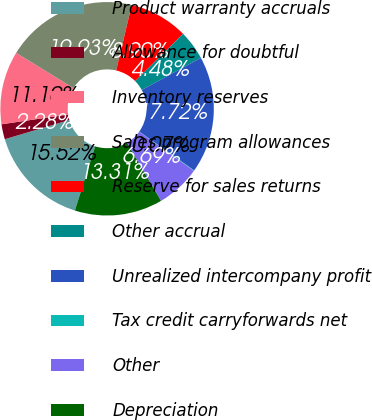Convert chart to OTSL. <chart><loc_0><loc_0><loc_500><loc_500><pie_chart><fcel>Product warranty accruals<fcel>Allowance for doubtful<fcel>Inventory reserves<fcel>Sales program allowances<fcel>Reserve for sales returns<fcel>Other accrual<fcel>Unrealized intercompany profit<fcel>Tax credit carryforwards net<fcel>Other<fcel>Depreciation<nl><fcel>15.52%<fcel>2.28%<fcel>11.1%<fcel>19.93%<fcel>8.9%<fcel>4.48%<fcel>17.72%<fcel>0.07%<fcel>6.69%<fcel>13.31%<nl></chart> 